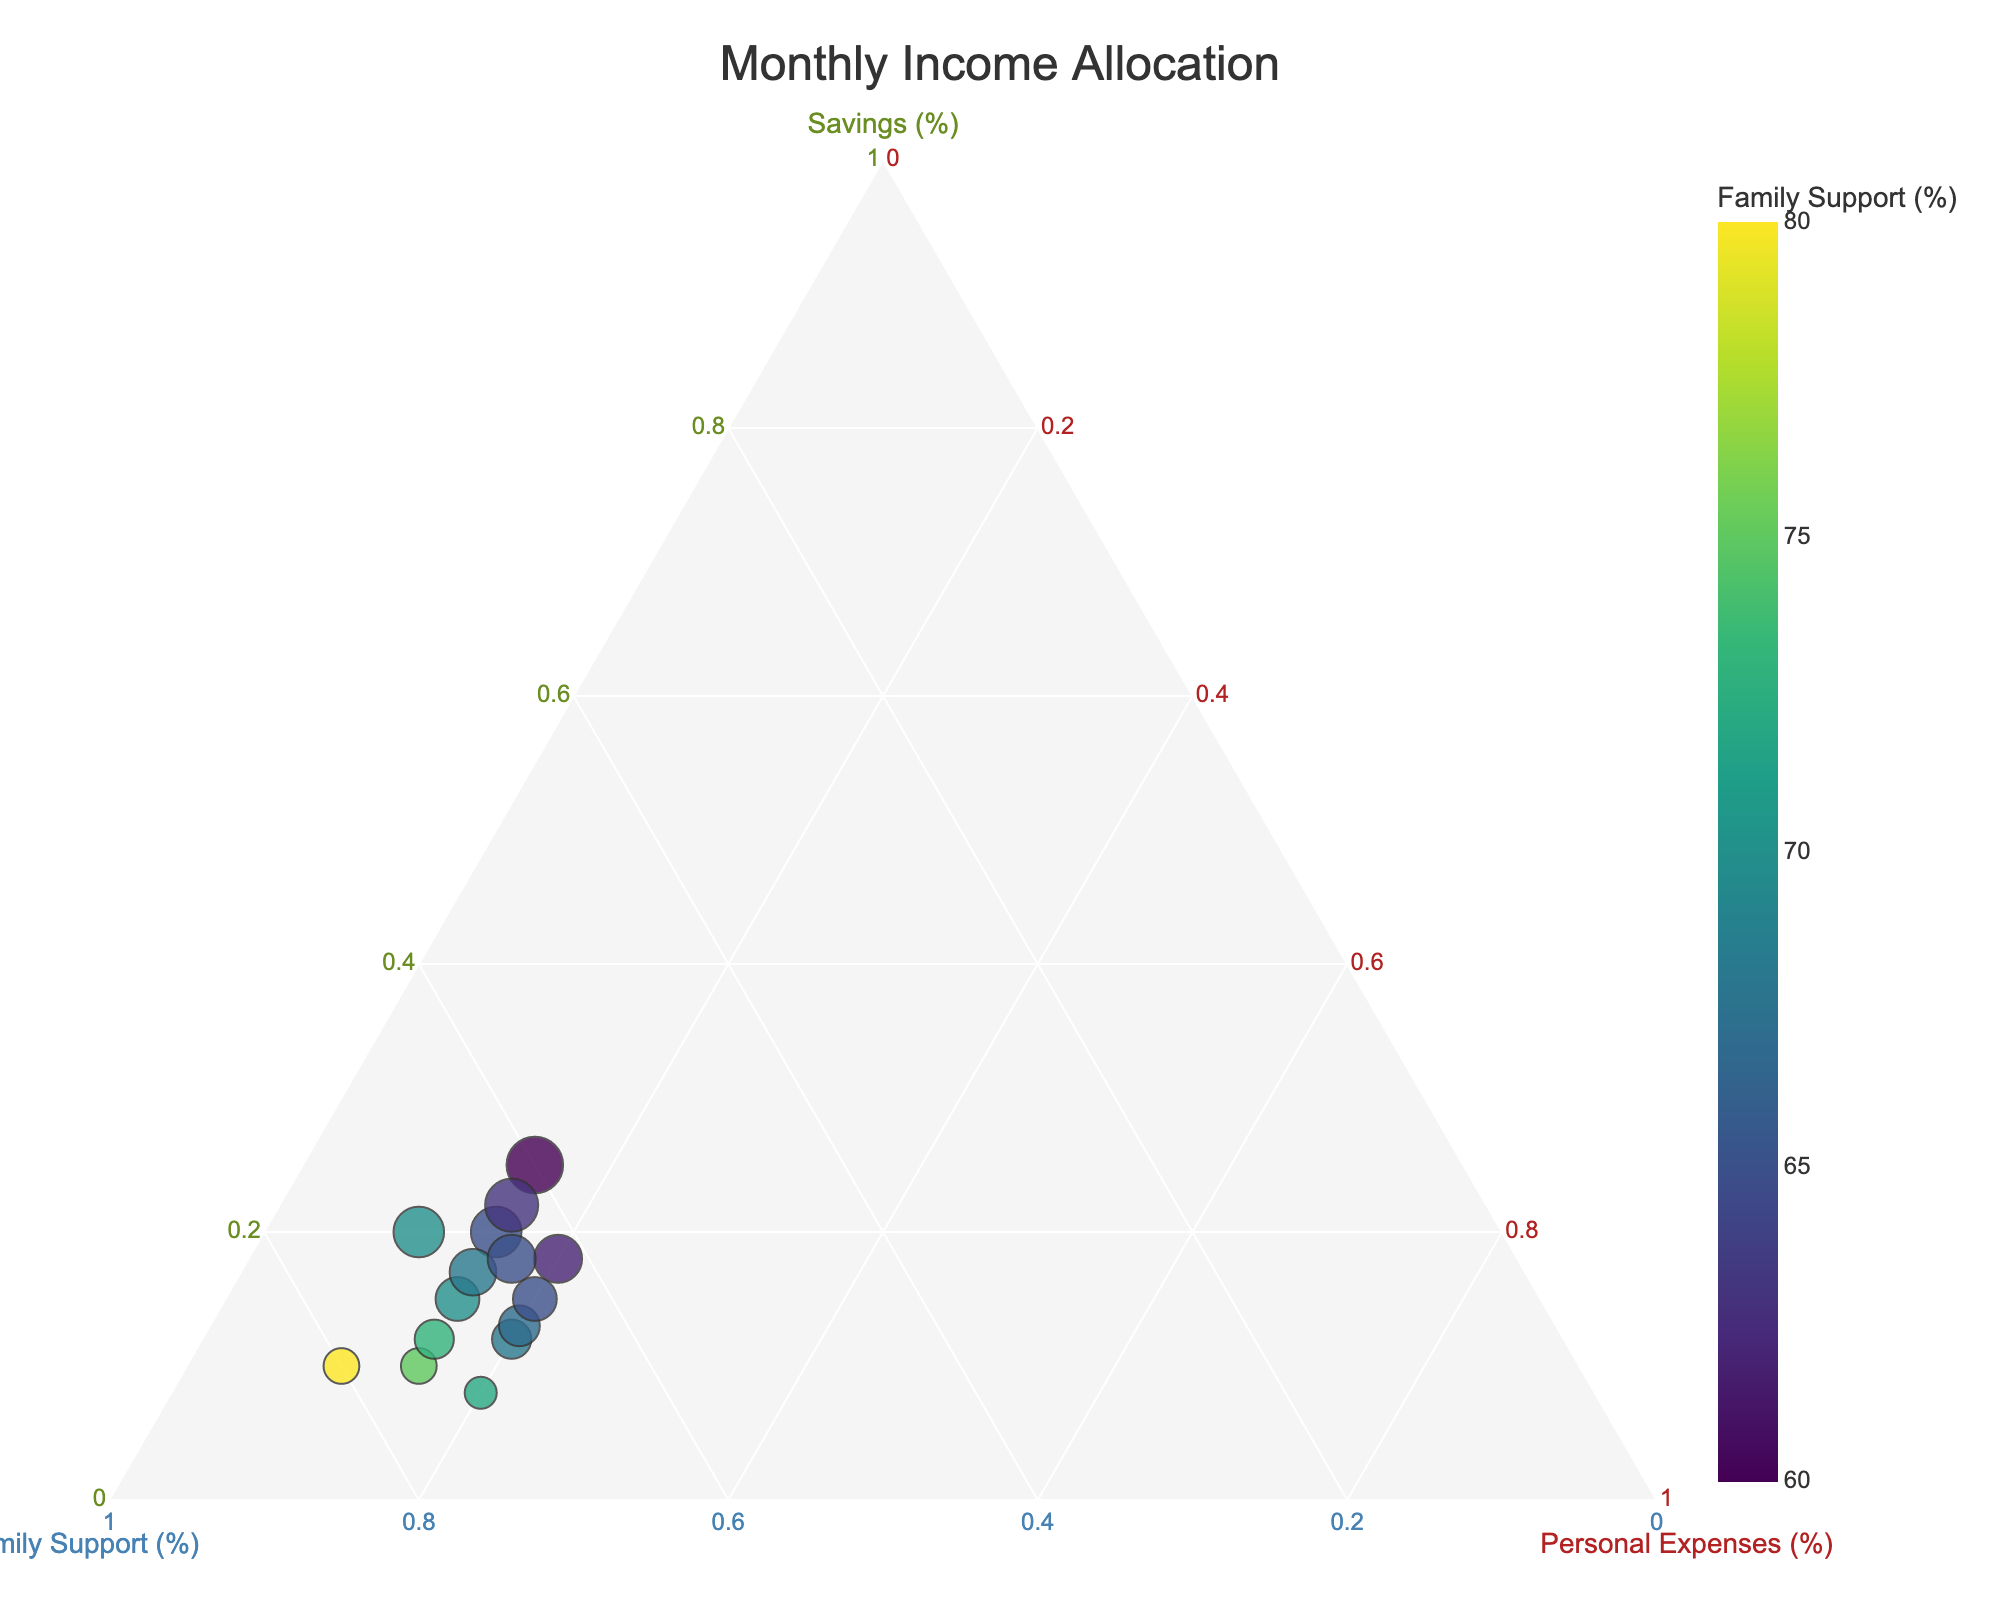What's the title of the figure? Look at the top of the plot, where the title is generally located.
Answer: Monthly Income Allocation How many data points are represented in the plot? Count the number of points scattered across the plot area.
Answer: 15 What percentage range is shown for Family Support? Family Support percentage is represented by the second axis. Look at the minimum and maximum label values along that axis.
Answer: 60% to 80% Which category has the largest size markers? Marker size is proportional to the Savings percentage. Look for the largest markers and identify the corresponding category.
Answer: 25% Savings What's the color of the markers representing 70% Family Support? Identify the Family Support percentage value and note the corresponding color in the plot.
Answer: Viridis color scale, around greenish What is the average percentage of Savings across all data points? Add up all the Savings percentages and divide by the number of data points: (15+20+10+12+18+25+8+22+13+17+20+15+10+18+12)/15 = 17.
Answer: 17% Which marker has the highest Savings percentage, and what are the corresponding Family Support and Personal Expenses percentages? Find the largest marker size (25% Savings) and check the coordinates given in the data set.
Answer: 25% Savings, 60% Family Support, 15% Personal Expenses Is there a visible correlation between Family Support and Savings? Observe the plot and describe any trends seen between Family Support and Savings percentages.
Answer: Generally, higher Family Support correlates with lower Savings Are any data points with equal Savings and Personal Expenses percentages? Compare the Savings and Personal Expenses values from the data set and check if any pair is equal.
Answer: Yes, a few points (e.g., 15-15, 10-10) Which data point shows the highest percentage of Personal Expenses and what are the corresponding Savings and Family Support percentages? Identify the highest Personal Expenses percentage in the plot and check the corresponding coordinates.
Answer: 20% Personal Expenses, 12% Savings, 68% Family Support 